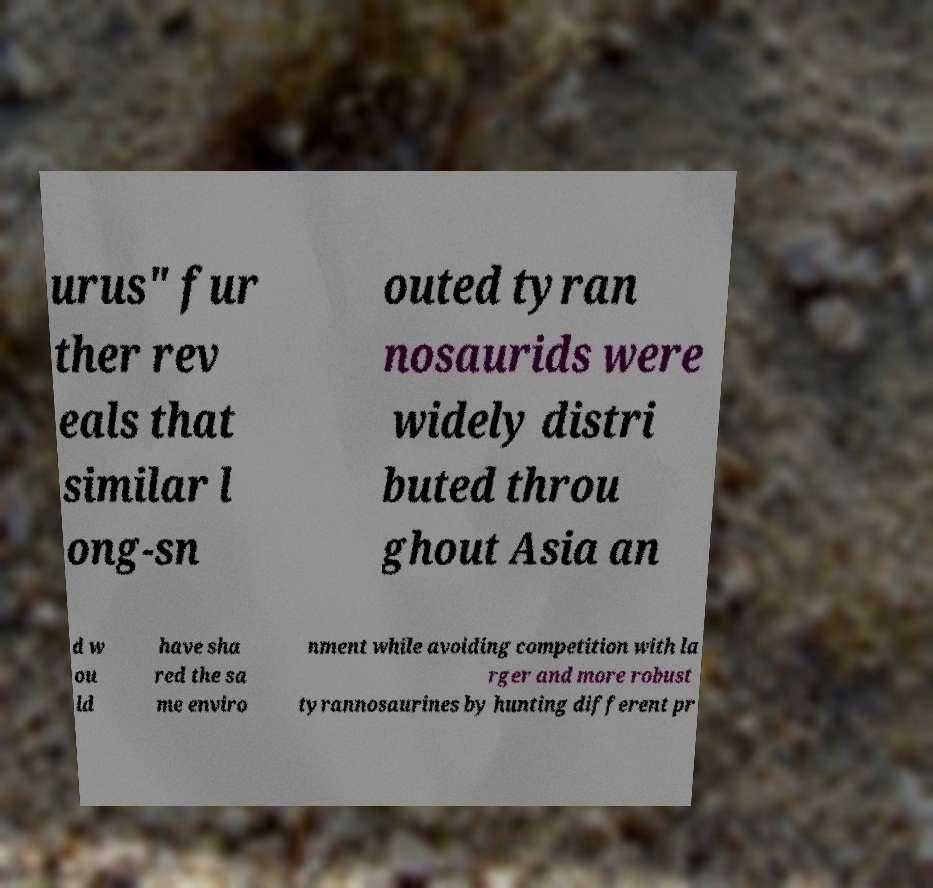There's text embedded in this image that I need extracted. Can you transcribe it verbatim? urus" fur ther rev eals that similar l ong-sn outed tyran nosaurids were widely distri buted throu ghout Asia an d w ou ld have sha red the sa me enviro nment while avoiding competition with la rger and more robust tyrannosaurines by hunting different pr 